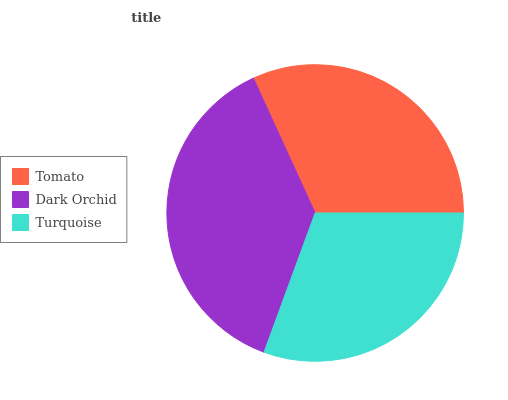Is Turquoise the minimum?
Answer yes or no. Yes. Is Dark Orchid the maximum?
Answer yes or no. Yes. Is Dark Orchid the minimum?
Answer yes or no. No. Is Turquoise the maximum?
Answer yes or no. No. Is Dark Orchid greater than Turquoise?
Answer yes or no. Yes. Is Turquoise less than Dark Orchid?
Answer yes or no. Yes. Is Turquoise greater than Dark Orchid?
Answer yes or no. No. Is Dark Orchid less than Turquoise?
Answer yes or no. No. Is Tomato the high median?
Answer yes or no. Yes. Is Tomato the low median?
Answer yes or no. Yes. Is Dark Orchid the high median?
Answer yes or no. No. Is Dark Orchid the low median?
Answer yes or no. No. 